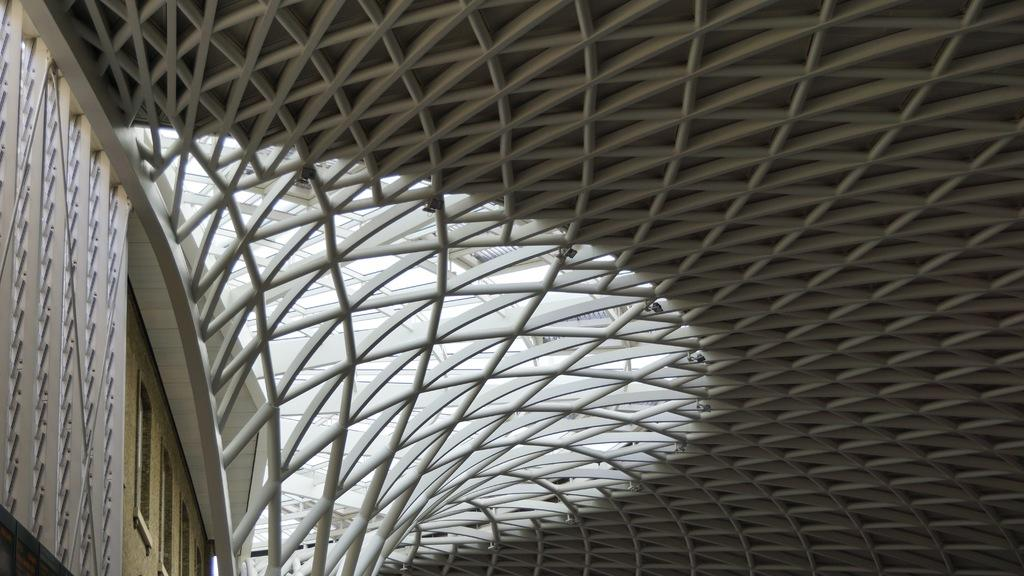What type of structure is depicted in the image? There is an architectural building in the image. Can you describe any specific features of the building? There are a few windows visible in the image. How many goldfish can be seen swimming in the land in the image? There are no goldfish or land present in the image; it features an architectural building with windows. 